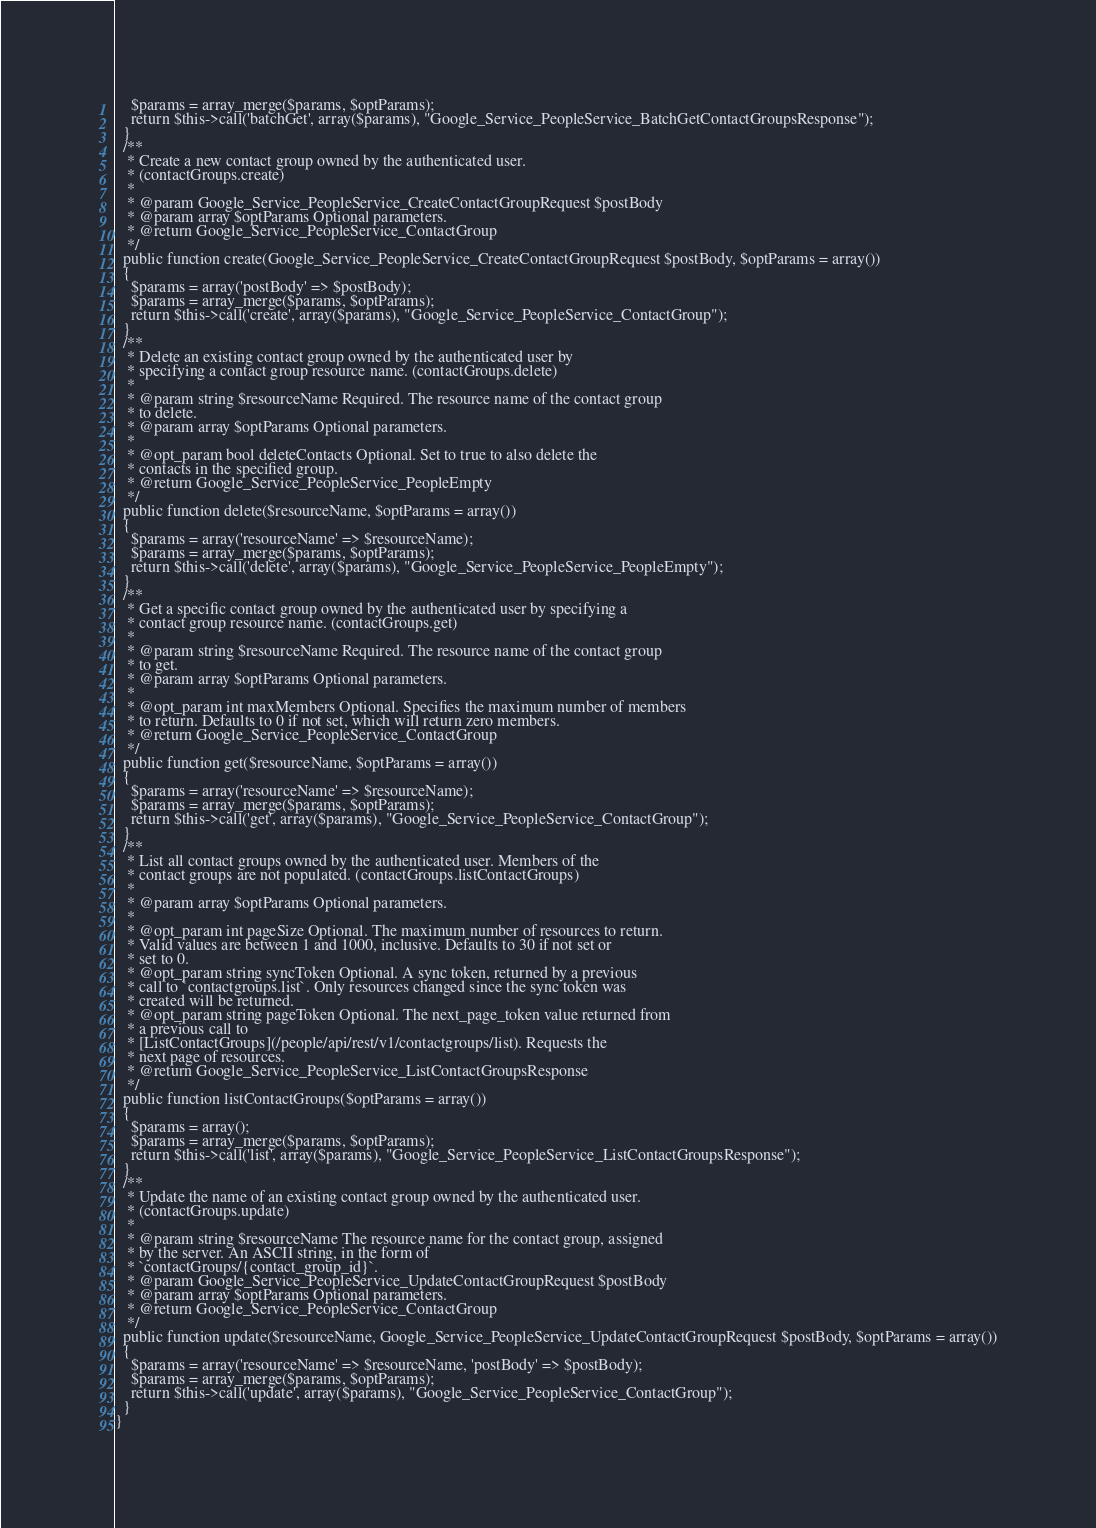<code> <loc_0><loc_0><loc_500><loc_500><_PHP_>    $params = array_merge($params, $optParams);
    return $this->call('batchGet', array($params), "Google_Service_PeopleService_BatchGetContactGroupsResponse");
  }
  /**
   * Create a new contact group owned by the authenticated user.
   * (contactGroups.create)
   *
   * @param Google_Service_PeopleService_CreateContactGroupRequest $postBody
   * @param array $optParams Optional parameters.
   * @return Google_Service_PeopleService_ContactGroup
   */
  public function create(Google_Service_PeopleService_CreateContactGroupRequest $postBody, $optParams = array())
  {
    $params = array('postBody' => $postBody);
    $params = array_merge($params, $optParams);
    return $this->call('create', array($params), "Google_Service_PeopleService_ContactGroup");
  }
  /**
   * Delete an existing contact group owned by the authenticated user by
   * specifying a contact group resource name. (contactGroups.delete)
   *
   * @param string $resourceName Required. The resource name of the contact group
   * to delete.
   * @param array $optParams Optional parameters.
   *
   * @opt_param bool deleteContacts Optional. Set to true to also delete the
   * contacts in the specified group.
   * @return Google_Service_PeopleService_PeopleEmpty
   */
  public function delete($resourceName, $optParams = array())
  {
    $params = array('resourceName' => $resourceName);
    $params = array_merge($params, $optParams);
    return $this->call('delete', array($params), "Google_Service_PeopleService_PeopleEmpty");
  }
  /**
   * Get a specific contact group owned by the authenticated user by specifying a
   * contact group resource name. (contactGroups.get)
   *
   * @param string $resourceName Required. The resource name of the contact group
   * to get.
   * @param array $optParams Optional parameters.
   *
   * @opt_param int maxMembers Optional. Specifies the maximum number of members
   * to return. Defaults to 0 if not set, which will return zero members.
   * @return Google_Service_PeopleService_ContactGroup
   */
  public function get($resourceName, $optParams = array())
  {
    $params = array('resourceName' => $resourceName);
    $params = array_merge($params, $optParams);
    return $this->call('get', array($params), "Google_Service_PeopleService_ContactGroup");
  }
  /**
   * List all contact groups owned by the authenticated user. Members of the
   * contact groups are not populated. (contactGroups.listContactGroups)
   *
   * @param array $optParams Optional parameters.
   *
   * @opt_param int pageSize Optional. The maximum number of resources to return.
   * Valid values are between 1 and 1000, inclusive. Defaults to 30 if not set or
   * set to 0.
   * @opt_param string syncToken Optional. A sync token, returned by a previous
   * call to `contactgroups.list`. Only resources changed since the sync token was
   * created will be returned.
   * @opt_param string pageToken Optional. The next_page_token value returned from
   * a previous call to
   * [ListContactGroups](/people/api/rest/v1/contactgroups/list). Requests the
   * next page of resources.
   * @return Google_Service_PeopleService_ListContactGroupsResponse
   */
  public function listContactGroups($optParams = array())
  {
    $params = array();
    $params = array_merge($params, $optParams);
    return $this->call('list', array($params), "Google_Service_PeopleService_ListContactGroupsResponse");
  }
  /**
   * Update the name of an existing contact group owned by the authenticated user.
   * (contactGroups.update)
   *
   * @param string $resourceName The resource name for the contact group, assigned
   * by the server. An ASCII string, in the form of
   * `contactGroups/{contact_group_id}`.
   * @param Google_Service_PeopleService_UpdateContactGroupRequest $postBody
   * @param array $optParams Optional parameters.
   * @return Google_Service_PeopleService_ContactGroup
   */
  public function update($resourceName, Google_Service_PeopleService_UpdateContactGroupRequest $postBody, $optParams = array())
  {
    $params = array('resourceName' => $resourceName, 'postBody' => $postBody);
    $params = array_merge($params, $optParams);
    return $this->call('update', array($params), "Google_Service_PeopleService_ContactGroup");
  }
}
</code> 